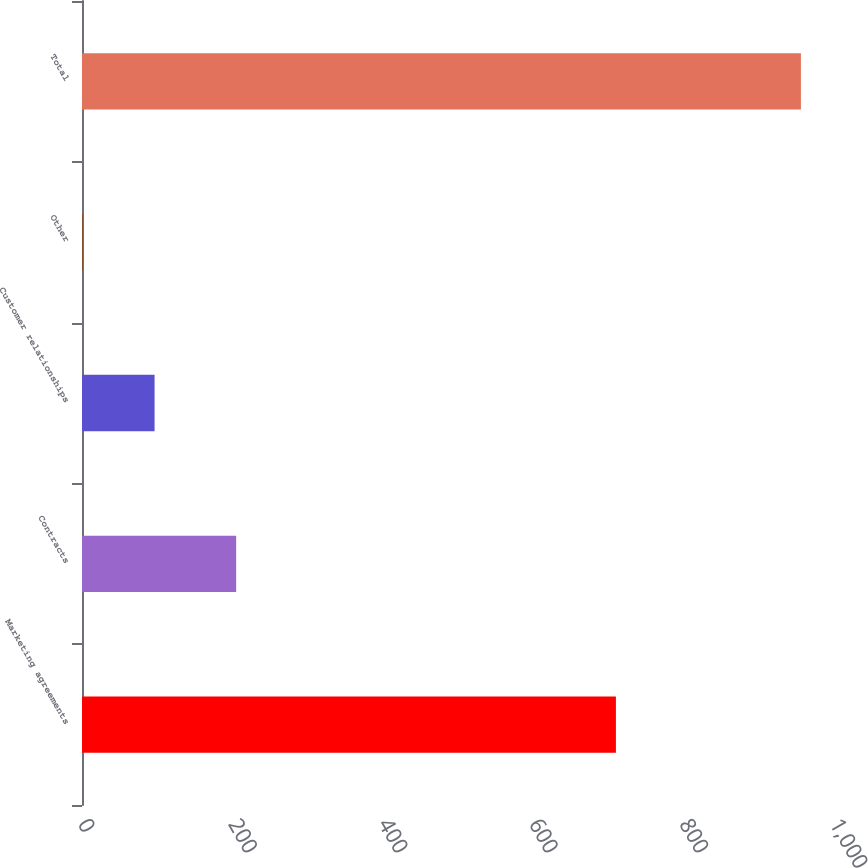Convert chart to OTSL. <chart><loc_0><loc_0><loc_500><loc_500><bar_chart><fcel>Marketing agreements<fcel>Contracts<fcel>Customer relationships<fcel>Other<fcel>Total<nl><fcel>710<fcel>205<fcel>96.5<fcel>1<fcel>956<nl></chart> 